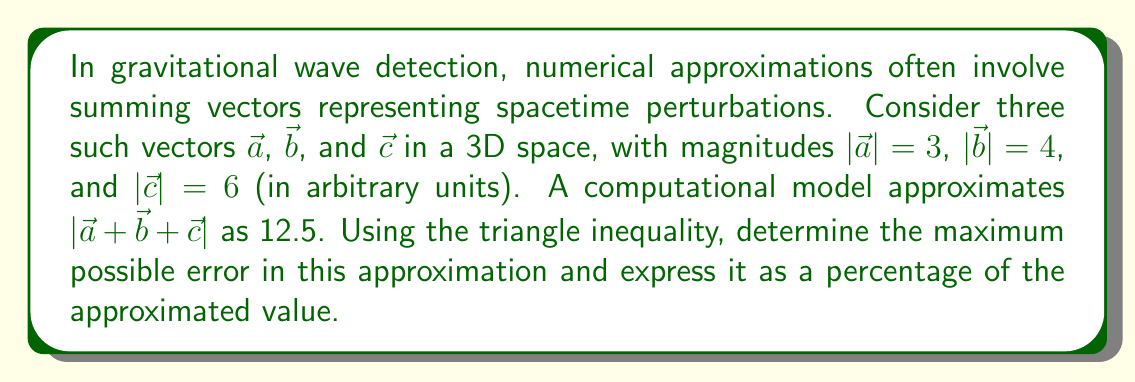Give your solution to this math problem. To solve this problem, we'll use the triangle inequality and compare the result with the given approximation:

1) The triangle inequality states that for any vectors $\vec{x}$ and $\vec{y}$:
   $$|\vec{x} + \vec{y}| \leq |\vec{x}| + |\vec{y}|$$

2) Extending this to three vectors:
   $$|\vec{a} + \vec{b} + \vec{c}| \leq |\vec{a}| + |\vec{b}| + |\vec{c}|$$

3) Substituting the given magnitudes:
   $$|\vec{a} + \vec{b} + \vec{c}| \leq 3 + 4 + 6 = 13$$

4) The triangle inequality gives us the upper bound. The lower bound is the largest magnitude minus the sum of the other two:
   $$|\vec{a} + \vec{b} + \vec{c}| \geq \max(|\vec{a}|, |\vec{b}|, |\vec{c}|) - (|\vec{a}| + |\vec{b}| + |\vec{c}| - \max(|\vec{a}|, |\vec{b}|, |\vec{c}|))$$
   $$= 6 - (3 + 4) = -1$$

   However, since magnitude is always non-negative, the actual lower bound is 0.

5) Therefore, the true value of $|\vec{a} + \vec{b} + \vec{c}|$ lies in the interval $[0, 13]$.

6) The computational model's approximation is 12.5, which falls within this interval.

7) The maximum possible error occurs if the true value is 0:
   Maximum error = $|12.5 - 0| = 12.5$

8) To express this as a percentage of the approximated value:
   Percentage error = $\frac{12.5}{12.5} \times 100\% = 100\%$

This analysis demonstrates that while the approximation falls within the theoretically possible range, the potential for error is significant, highlighting the importance of careful validation in numerical gravitational wave detection algorithms.
Answer: The maximum possible error in the approximation is 100% of the approximated value. 